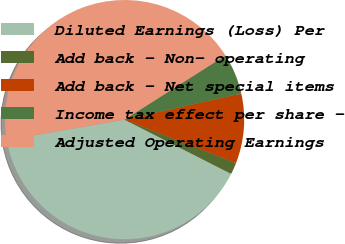Convert chart to OTSL. <chart><loc_0><loc_0><loc_500><loc_500><pie_chart><fcel>Diluted Earnings (Loss) Per<fcel>Add back - Non- operating<fcel>Add back - Net special items<fcel>Income tax effect per share -<fcel>Adjusted Operating Earnings<nl><fcel>39.79%<fcel>1.57%<fcel>9.42%<fcel>5.5%<fcel>43.72%<nl></chart> 